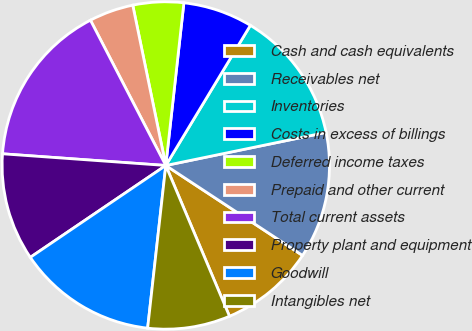Convert chart. <chart><loc_0><loc_0><loc_500><loc_500><pie_chart><fcel>Cash and cash equivalents<fcel>Receivables net<fcel>Inventories<fcel>Costs in excess of billings<fcel>Deferred income taxes<fcel>Prepaid and other current<fcel>Total current assets<fcel>Property plant and equipment<fcel>Goodwill<fcel>Intangibles net<nl><fcel>9.38%<fcel>12.5%<fcel>13.12%<fcel>6.88%<fcel>5.0%<fcel>4.38%<fcel>16.25%<fcel>10.62%<fcel>13.75%<fcel>8.13%<nl></chart> 